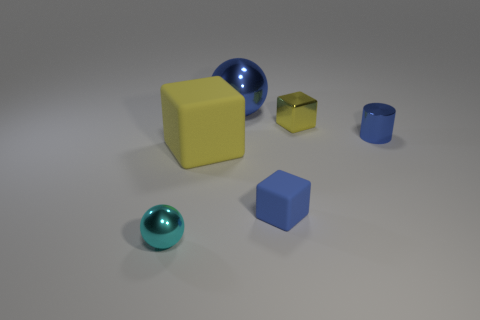What is the shape of the big object that is made of the same material as the blue cube?
Give a very brief answer. Cube. Is there anything else of the same color as the large metallic object?
Provide a succinct answer. Yes. Is the number of big yellow blocks in front of the small ball greater than the number of tiny shiny spheres that are behind the small matte object?
Your response must be concise. No. How many other cylinders are the same size as the metal cylinder?
Ensure brevity in your answer.  0. Are there fewer small yellow things left of the cyan metallic ball than large yellow matte cubes that are in front of the blue shiny cylinder?
Provide a short and direct response. Yes. Is there a small yellow thing of the same shape as the big yellow object?
Your answer should be very brief. Yes. Does the big yellow object have the same shape as the tiny rubber object?
Your answer should be very brief. Yes. How many tiny objects are either yellow blocks or purple blocks?
Give a very brief answer. 1. Are there more big red cubes than blue metal cylinders?
Your response must be concise. No. There is a yellow thing that is made of the same material as the cyan thing; what is its size?
Provide a succinct answer. Small. 